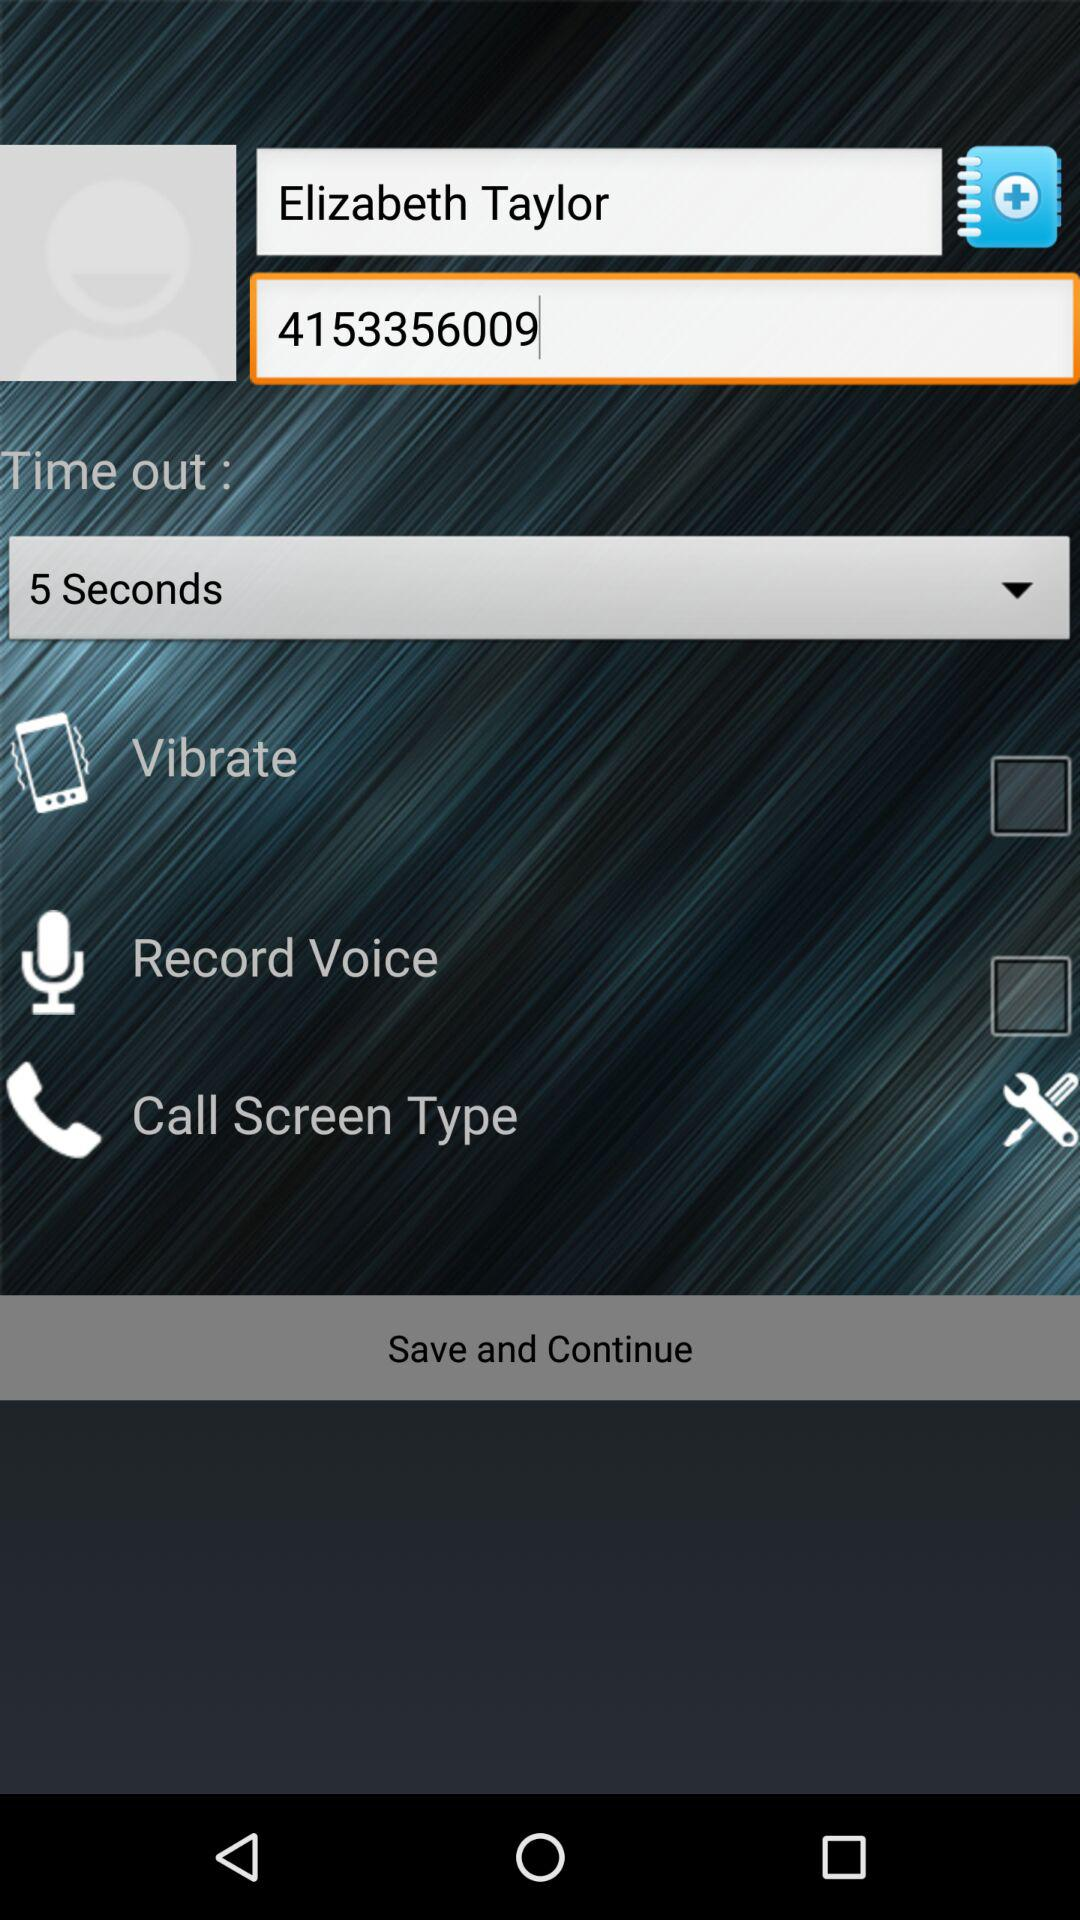Under what name is the contact number saved? The contact number is saved as Elizabeth Taylor. 